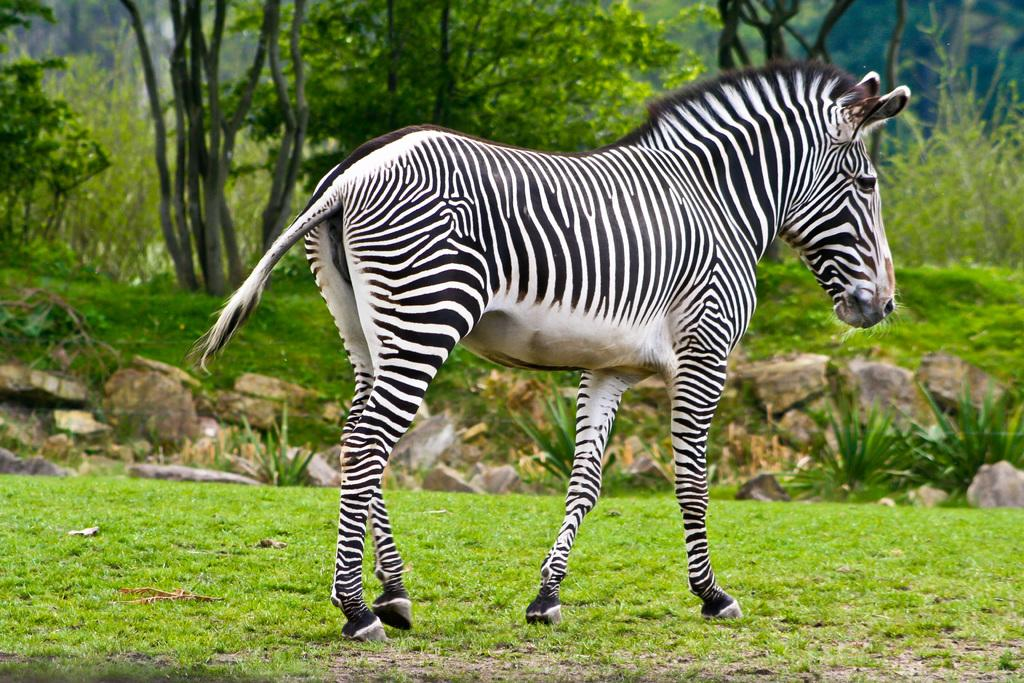What animal is present in the image? There is a zebra in the image. What type of terrain is visible in the image? The land is covered with grass. What can be seen in the background of the image? There are trees and plants in the background of the image. How many eggs are visible in the image? There are no eggs present in the image. What type of border surrounds the zebra in the image? There is no border surrounding the zebra in the image. 